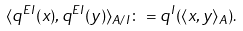Convert formula to latex. <formula><loc_0><loc_0><loc_500><loc_500>\langle q ^ { E I } ( x ) , q ^ { E I } ( y ) \rangle _ { A / I } \colon = q ^ { I } ( \langle x , y \rangle _ { A } ) .</formula> 